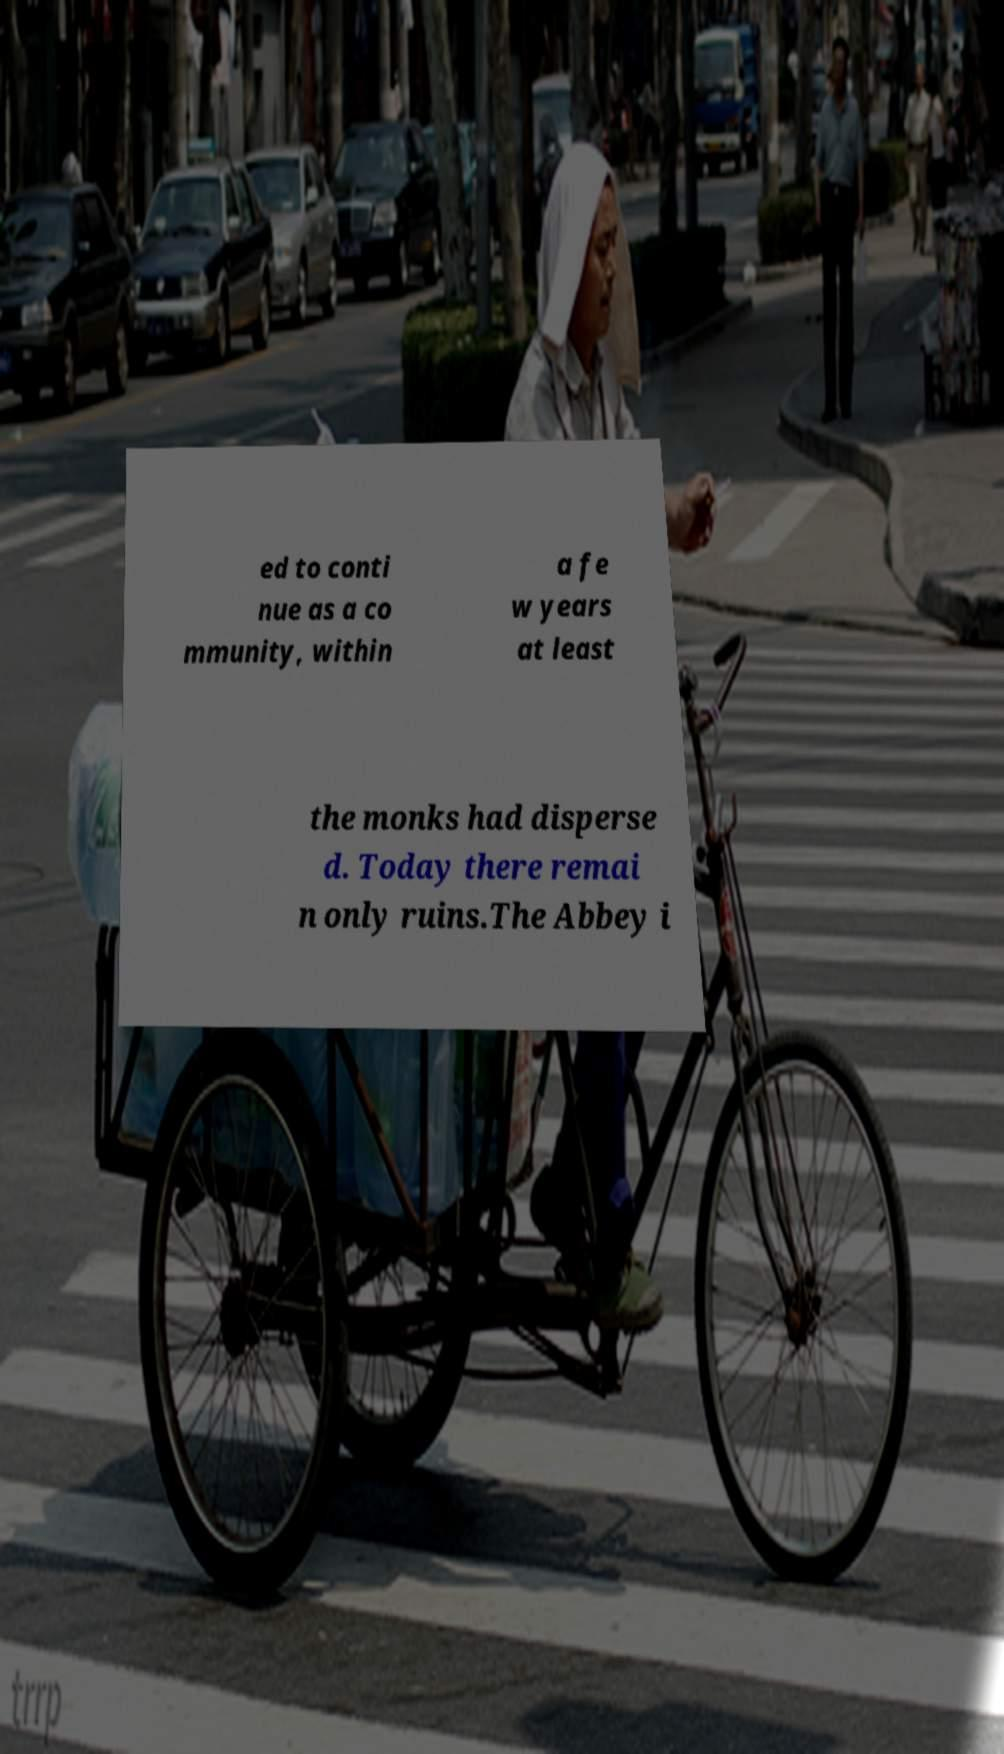I need the written content from this picture converted into text. Can you do that? ed to conti nue as a co mmunity, within a fe w years at least the monks had disperse d. Today there remai n only ruins.The Abbey i 